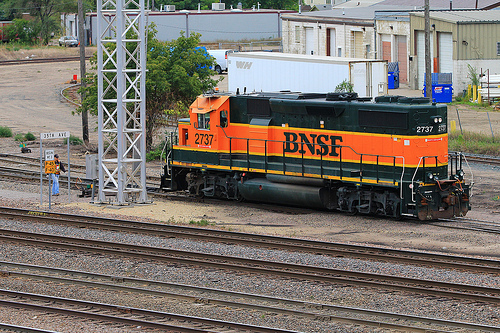How many trains are in the picture? There is one train visible in the picture, featuring a locomotive with the distinctive green and orange livery of the BNSF Railway. 